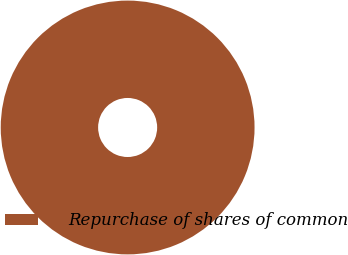Convert chart. <chart><loc_0><loc_0><loc_500><loc_500><pie_chart><fcel>Repurchase of shares of common<nl><fcel>100.0%<nl></chart> 